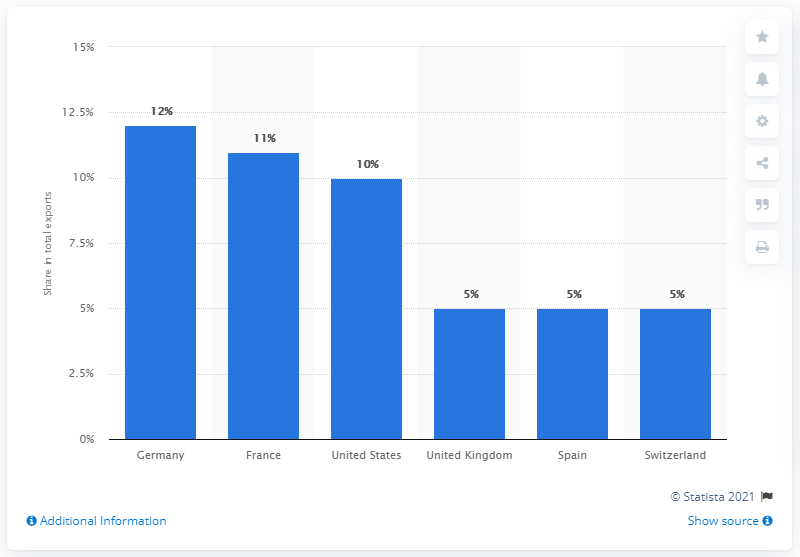Highlight a few significant elements in this photo. In 2019, Germany was the primary export partner of Italy, accounting for a significant portion of the country's total exports. 